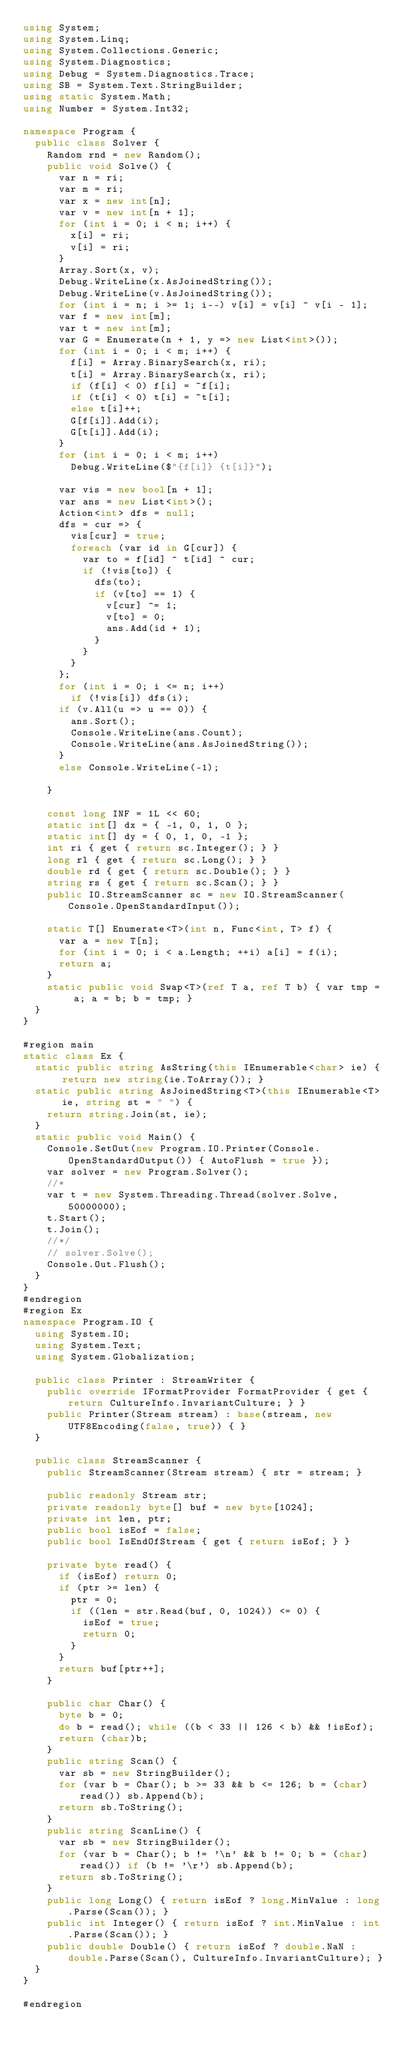<code> <loc_0><loc_0><loc_500><loc_500><_C#_>using System;
using System.Linq;
using System.Collections.Generic;
using System.Diagnostics;
using Debug = System.Diagnostics.Trace;
using SB = System.Text.StringBuilder;
using static System.Math;
using Number = System.Int32;

namespace Program {
	public class Solver {
		Random rnd = new Random();
		public void Solve() {
			var n = ri;
			var m = ri;
			var x = new int[n];
			var v = new int[n + 1];
			for (int i = 0; i < n; i++) {
				x[i] = ri;
				v[i] = ri;
			}
			Array.Sort(x, v);
			Debug.WriteLine(x.AsJoinedString());
			Debug.WriteLine(v.AsJoinedString());
			for (int i = n; i >= 1; i--) v[i] = v[i] ^ v[i - 1];
			var f = new int[m];
			var t = new int[m];
			var G = Enumerate(n + 1, y => new List<int>());
			for (int i = 0; i < m; i++) {
				f[i] = Array.BinarySearch(x, ri);
				t[i] = Array.BinarySearch(x, ri);
				if (f[i] < 0) f[i] = ~f[i];
				if (t[i] < 0) t[i] = ~t[i];
				else t[i]++;
				G[f[i]].Add(i);
				G[t[i]].Add(i);
			}
			for (int i = 0; i < m; i++)
				Debug.WriteLine($"{f[i]} {t[i]}");

			var vis = new bool[n + 1];
			var ans = new List<int>();
			Action<int> dfs = null;
			dfs = cur => {
				vis[cur] = true;
				foreach (var id in G[cur]) {
					var to = f[id] ^ t[id] ^ cur;
					if (!vis[to]) {
						dfs(to);
						if (v[to] == 1) {
							v[cur] ^= 1;
							v[to] = 0;
							ans.Add(id + 1);
						}
					}
				}
			};
			for (int i = 0; i <= n; i++)
				if (!vis[i]) dfs(i);
			if (v.All(u => u == 0)) {
				ans.Sort();
				Console.WriteLine(ans.Count);
				Console.WriteLine(ans.AsJoinedString());
			}
			else Console.WriteLine(-1);

		}

		const long INF = 1L << 60;
		static int[] dx = { -1, 0, 1, 0 };
		static int[] dy = { 0, 1, 0, -1 };
		int ri { get { return sc.Integer(); } }
		long rl { get { return sc.Long(); } }
		double rd { get { return sc.Double(); } }
		string rs { get { return sc.Scan(); } }
		public IO.StreamScanner sc = new IO.StreamScanner(Console.OpenStandardInput());

		static T[] Enumerate<T>(int n, Func<int, T> f) {
			var a = new T[n];
			for (int i = 0; i < a.Length; ++i) a[i] = f(i);
			return a;
		}
		static public void Swap<T>(ref T a, ref T b) { var tmp = a; a = b; b = tmp; }
	}
}

#region main
static class Ex {
	static public string AsString(this IEnumerable<char> ie) { return new string(ie.ToArray()); }
	static public string AsJoinedString<T>(this IEnumerable<T> ie, string st = " ") {
		return string.Join(st, ie);
	}
	static public void Main() {
		Console.SetOut(new Program.IO.Printer(Console.OpenStandardOutput()) { AutoFlush = true });
		var solver = new Program.Solver();
		//* 
		var t = new System.Threading.Thread(solver.Solve, 50000000);
		t.Start();
		t.Join();
		//*/
		// solver.Solve();
		Console.Out.Flush();
	}
}
#endregion
#region Ex
namespace Program.IO {
	using System.IO;
	using System.Text;
	using System.Globalization;

	public class Printer : StreamWriter {
		public override IFormatProvider FormatProvider { get { return CultureInfo.InvariantCulture; } }
		public Printer(Stream stream) : base(stream, new UTF8Encoding(false, true)) { }
	}

	public class StreamScanner {
		public StreamScanner(Stream stream) { str = stream; }

		public readonly Stream str;
		private readonly byte[] buf = new byte[1024];
		private int len, ptr;
		public bool isEof = false;
		public bool IsEndOfStream { get { return isEof; } }

		private byte read() {
			if (isEof) return 0;
			if (ptr >= len) {
				ptr = 0;
				if ((len = str.Read(buf, 0, 1024)) <= 0) {
					isEof = true;
					return 0;
				}
			}
			return buf[ptr++];
		}

		public char Char() {
			byte b = 0;
			do b = read(); while ((b < 33 || 126 < b) && !isEof);
			return (char)b;
		}
		public string Scan() {
			var sb = new StringBuilder();
			for (var b = Char(); b >= 33 && b <= 126; b = (char)read()) sb.Append(b);
			return sb.ToString();
		}
		public string ScanLine() {
			var sb = new StringBuilder();
			for (var b = Char(); b != '\n' && b != 0; b = (char)read()) if (b != '\r') sb.Append(b);
			return sb.ToString();
		}
		public long Long() { return isEof ? long.MinValue : long.Parse(Scan()); }
		public int Integer() { return isEof ? int.MinValue : int.Parse(Scan()); }
		public double Double() { return isEof ? double.NaN : double.Parse(Scan(), CultureInfo.InvariantCulture); }
	}
}

#endregion

</code> 